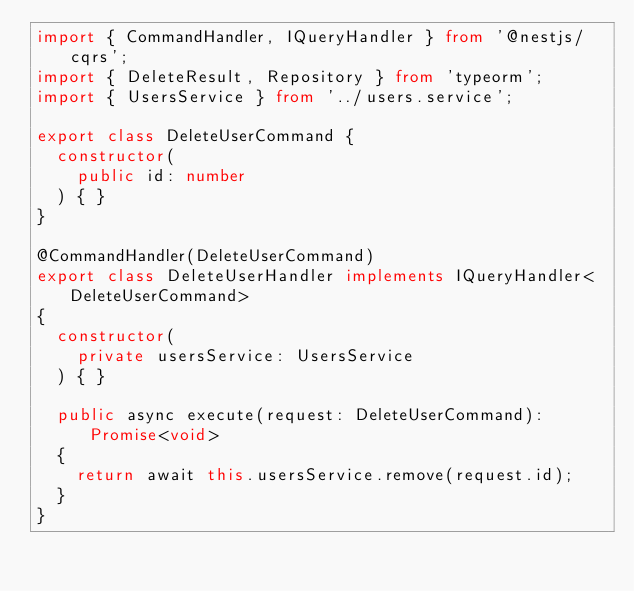<code> <loc_0><loc_0><loc_500><loc_500><_TypeScript_>import { CommandHandler, IQueryHandler } from '@nestjs/cqrs';
import { DeleteResult, Repository } from 'typeorm';
import { UsersService } from '../users.service';

export class DeleteUserCommand {
  constructor(
    public id: number
  ) { }
}

@CommandHandler(DeleteUserCommand)
export class DeleteUserHandler implements IQueryHandler<DeleteUserCommand>
{
  constructor(
    private usersService: UsersService
  ) { }

  public async execute(request: DeleteUserCommand): Promise<void>
  {
    return await this.usersService.remove(request.id);
  }
}</code> 